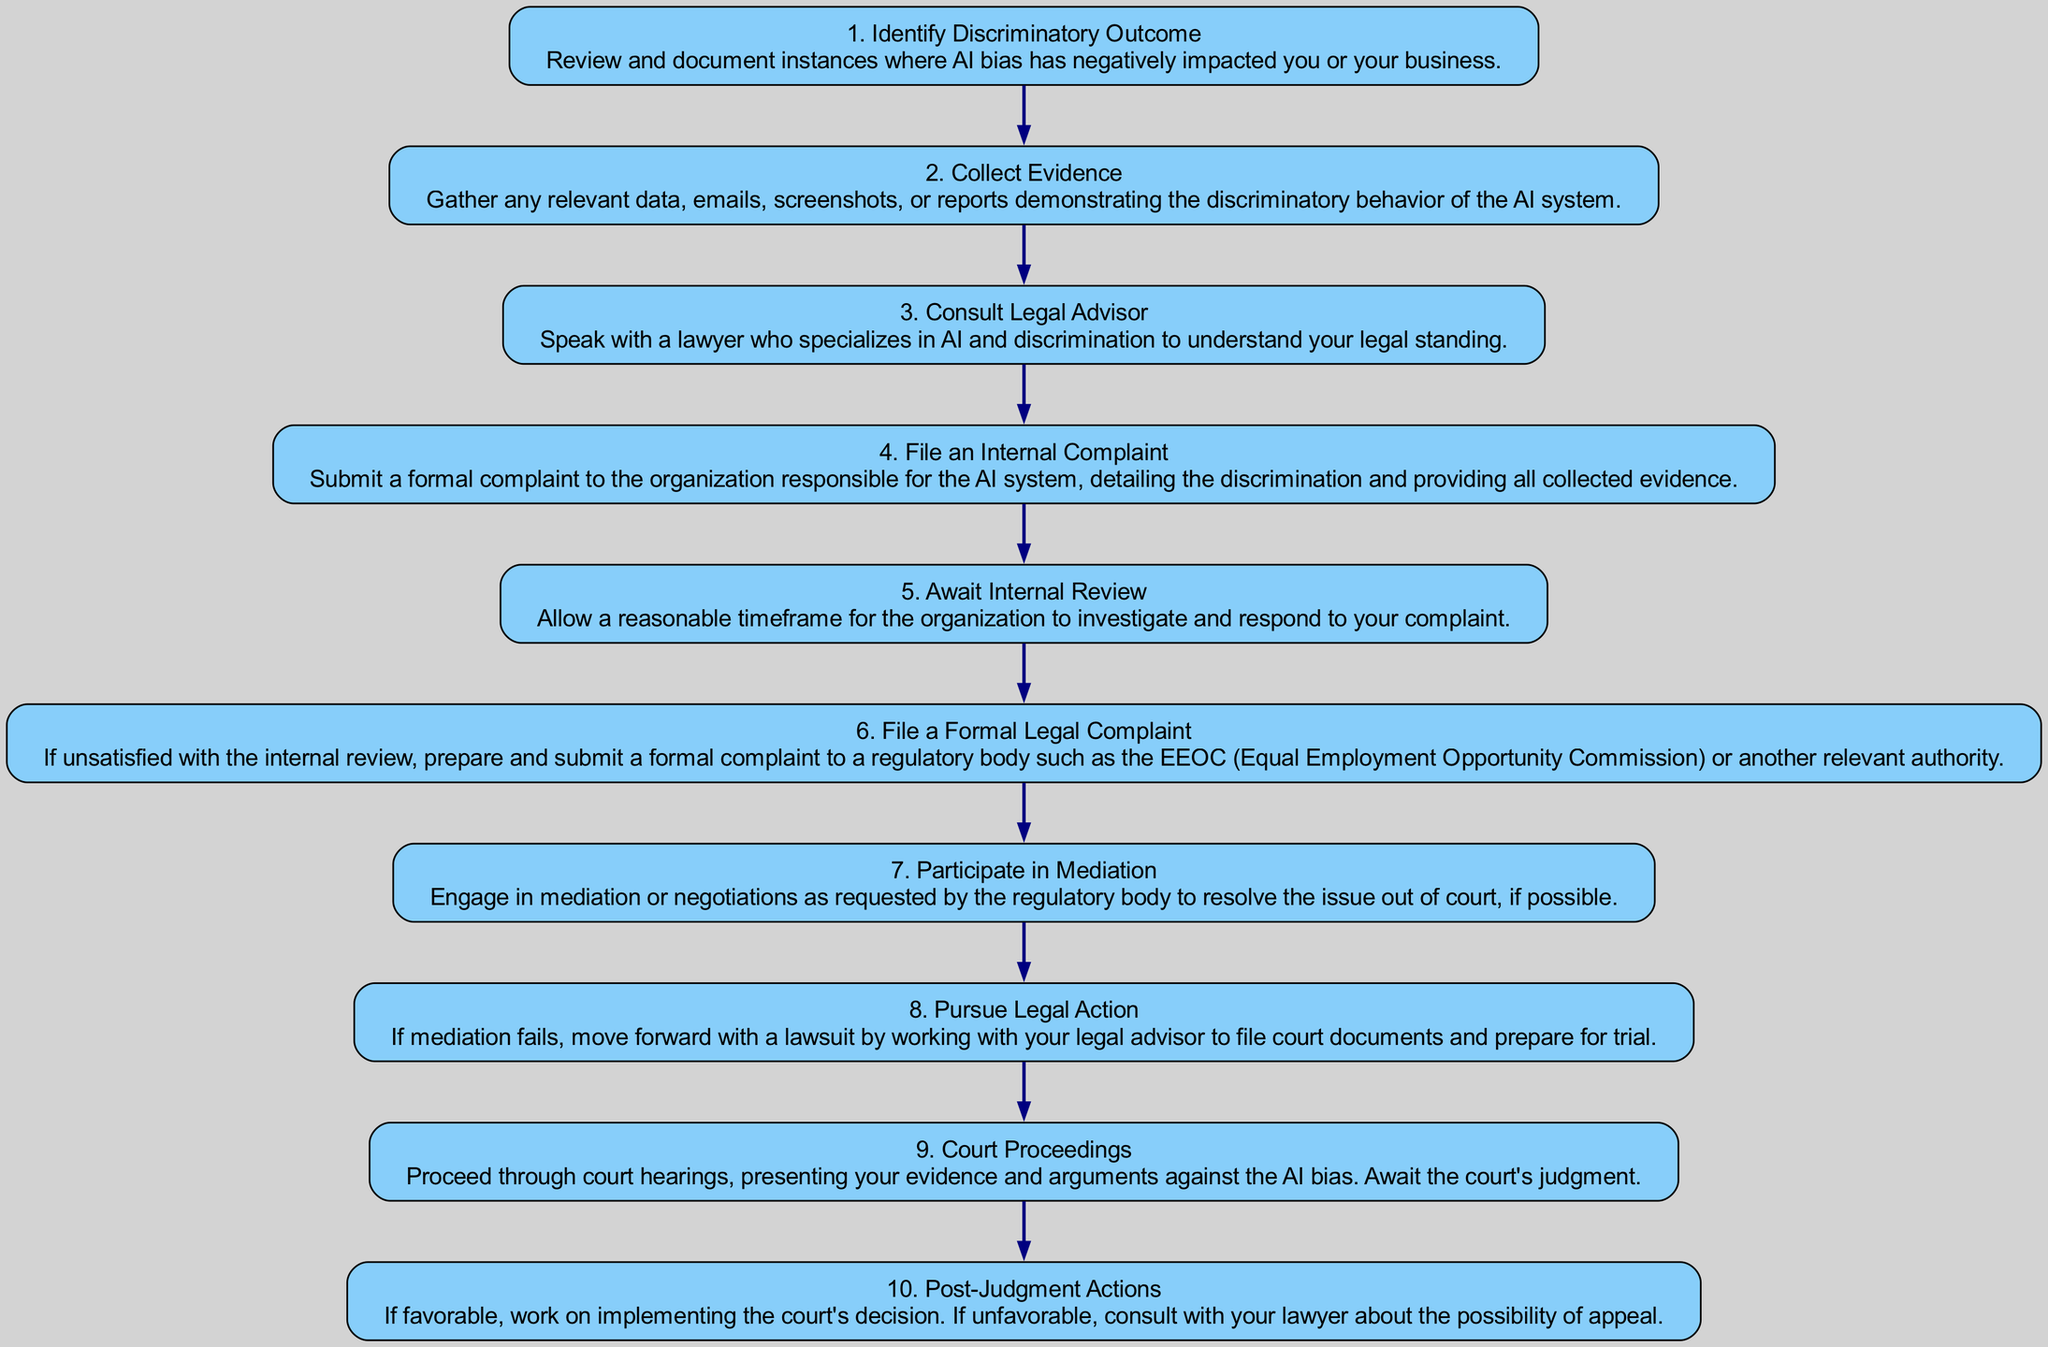What is the first step in the complaint process? The diagram indicates that the first step is to "Identify Discriminatory Outcome," where the individual reviews and documents instances of AI bias affecting them.
Answer: Identify Discriminatory Outcome How many steps are there in the process? The total number of steps in the diagram is ten, as each step is distinctly listed from one to ten.
Answer: Ten What step follows the collection of evidence? Following the "Collect Evidence" step, the next step is "Consult Legal Advisor," where advice from a specialist lawyer is sought.
Answer: Consult Legal Advisor What action is taken if the internal review is unsatisfactory? If the internal review does not satisfy the individual, the next action is to "File a Formal Legal Complaint" to a regulatory body.
Answer: File a Formal Legal Complaint Which step involves mediation? The "Participate in Mediation" step involves engaging in mediation or negotiations as requested by the regulatory body.
Answer: Participate in Mediation In what step are court documents prepared? In the "Pursue Legal Action" step, the individual prepares court documents in collaboration with their legal advisor to proceed with a lawsuit.
Answer: Pursue Legal Action What two actions can be taken after receiving a court judgment? After the judgment, either implementing the court's decision or consulting about an appeal is possible, as indicated in the final step.
Answer: Implementing the court's decision or appealing What is the primary focus of the steps outlined in the diagram? The primary focus of the steps is to provide a structured pathway for individuals filing a complaint regarding AI discrimination.
Answer: Filing a complaint regarding AI discrimination 